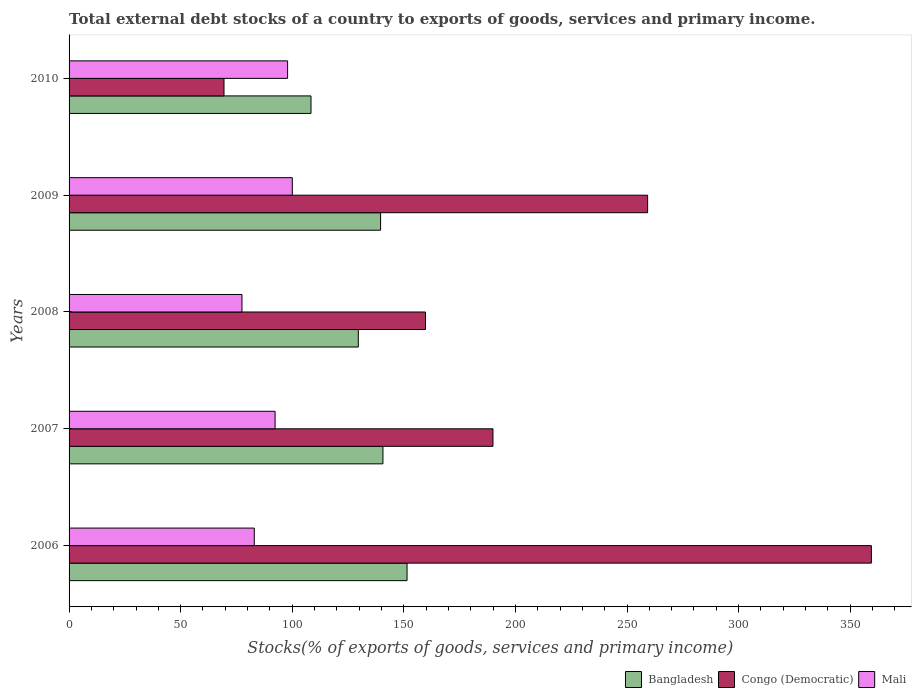How many groups of bars are there?
Provide a succinct answer. 5. Are the number of bars per tick equal to the number of legend labels?
Provide a short and direct response. Yes. How many bars are there on the 3rd tick from the bottom?
Your answer should be compact. 3. What is the label of the 4th group of bars from the top?
Offer a very short reply. 2007. In how many cases, is the number of bars for a given year not equal to the number of legend labels?
Give a very brief answer. 0. What is the total debt stocks in Mali in 2009?
Ensure brevity in your answer.  100.03. Across all years, what is the maximum total debt stocks in Mali?
Keep it short and to the point. 100.03. Across all years, what is the minimum total debt stocks in Congo (Democratic)?
Your answer should be very brief. 69.42. In which year was the total debt stocks in Mali maximum?
Offer a terse response. 2009. In which year was the total debt stocks in Bangladesh minimum?
Your response must be concise. 2010. What is the total total debt stocks in Congo (Democratic) in the graph?
Provide a succinct answer. 1037.78. What is the difference between the total debt stocks in Mali in 2006 and that in 2007?
Your answer should be compact. -9.32. What is the difference between the total debt stocks in Mali in 2010 and the total debt stocks in Congo (Democratic) in 2006?
Your answer should be very brief. -261.57. What is the average total debt stocks in Mali per year?
Keep it short and to the point. 90.14. In the year 2006, what is the difference between the total debt stocks in Congo (Democratic) and total debt stocks in Bangladesh?
Ensure brevity in your answer.  208.05. What is the ratio of the total debt stocks in Mali in 2007 to that in 2008?
Offer a very short reply. 1.19. Is the total debt stocks in Bangladesh in 2006 less than that in 2010?
Your response must be concise. No. Is the difference between the total debt stocks in Congo (Democratic) in 2006 and 2007 greater than the difference between the total debt stocks in Bangladesh in 2006 and 2007?
Keep it short and to the point. Yes. What is the difference between the highest and the second highest total debt stocks in Mali?
Offer a terse response. 2.12. What is the difference between the highest and the lowest total debt stocks in Congo (Democratic)?
Give a very brief answer. 290.07. In how many years, is the total debt stocks in Mali greater than the average total debt stocks in Mali taken over all years?
Provide a succinct answer. 3. Is the sum of the total debt stocks in Congo (Democratic) in 2008 and 2009 greater than the maximum total debt stocks in Mali across all years?
Offer a terse response. Yes. What does the 1st bar from the top in 2009 represents?
Offer a very short reply. Mali. What does the 2nd bar from the bottom in 2010 represents?
Ensure brevity in your answer.  Congo (Democratic). How many bars are there?
Your answer should be compact. 15. How many years are there in the graph?
Your answer should be very brief. 5. What is the difference between two consecutive major ticks on the X-axis?
Keep it short and to the point. 50. Are the values on the major ticks of X-axis written in scientific E-notation?
Make the answer very short. No. Does the graph contain any zero values?
Make the answer very short. No. Does the graph contain grids?
Ensure brevity in your answer.  No. Where does the legend appear in the graph?
Ensure brevity in your answer.  Bottom right. How are the legend labels stacked?
Your response must be concise. Horizontal. What is the title of the graph?
Make the answer very short. Total external debt stocks of a country to exports of goods, services and primary income. What is the label or title of the X-axis?
Offer a terse response. Stocks(% of exports of goods, services and primary income). What is the Stocks(% of exports of goods, services and primary income) of Bangladesh in 2006?
Make the answer very short. 151.43. What is the Stocks(% of exports of goods, services and primary income) of Congo (Democratic) in 2006?
Your answer should be very brief. 359.49. What is the Stocks(% of exports of goods, services and primary income) of Mali in 2006?
Offer a very short reply. 82.99. What is the Stocks(% of exports of goods, services and primary income) in Bangladesh in 2007?
Ensure brevity in your answer.  140.64. What is the Stocks(% of exports of goods, services and primary income) in Congo (Democratic) in 2007?
Provide a short and direct response. 189.94. What is the Stocks(% of exports of goods, services and primary income) of Mali in 2007?
Offer a terse response. 92.31. What is the Stocks(% of exports of goods, services and primary income) in Bangladesh in 2008?
Ensure brevity in your answer.  129.6. What is the Stocks(% of exports of goods, services and primary income) of Congo (Democratic) in 2008?
Your answer should be compact. 159.7. What is the Stocks(% of exports of goods, services and primary income) of Mali in 2008?
Offer a very short reply. 77.47. What is the Stocks(% of exports of goods, services and primary income) of Bangladesh in 2009?
Make the answer very short. 139.58. What is the Stocks(% of exports of goods, services and primary income) in Congo (Democratic) in 2009?
Your response must be concise. 259.23. What is the Stocks(% of exports of goods, services and primary income) of Mali in 2009?
Ensure brevity in your answer.  100.03. What is the Stocks(% of exports of goods, services and primary income) in Bangladesh in 2010?
Your response must be concise. 108.4. What is the Stocks(% of exports of goods, services and primary income) in Congo (Democratic) in 2010?
Your response must be concise. 69.42. What is the Stocks(% of exports of goods, services and primary income) of Mali in 2010?
Ensure brevity in your answer.  97.91. Across all years, what is the maximum Stocks(% of exports of goods, services and primary income) of Bangladesh?
Keep it short and to the point. 151.43. Across all years, what is the maximum Stocks(% of exports of goods, services and primary income) of Congo (Democratic)?
Provide a short and direct response. 359.49. Across all years, what is the maximum Stocks(% of exports of goods, services and primary income) in Mali?
Your answer should be compact. 100.03. Across all years, what is the minimum Stocks(% of exports of goods, services and primary income) in Bangladesh?
Offer a very short reply. 108.4. Across all years, what is the minimum Stocks(% of exports of goods, services and primary income) in Congo (Democratic)?
Offer a very short reply. 69.42. Across all years, what is the minimum Stocks(% of exports of goods, services and primary income) in Mali?
Your answer should be compact. 77.47. What is the total Stocks(% of exports of goods, services and primary income) in Bangladesh in the graph?
Offer a very short reply. 669.65. What is the total Stocks(% of exports of goods, services and primary income) in Congo (Democratic) in the graph?
Make the answer very short. 1037.78. What is the total Stocks(% of exports of goods, services and primary income) in Mali in the graph?
Your response must be concise. 450.72. What is the difference between the Stocks(% of exports of goods, services and primary income) of Bangladesh in 2006 and that in 2007?
Provide a short and direct response. 10.8. What is the difference between the Stocks(% of exports of goods, services and primary income) in Congo (Democratic) in 2006 and that in 2007?
Provide a succinct answer. 169.55. What is the difference between the Stocks(% of exports of goods, services and primary income) in Mali in 2006 and that in 2007?
Provide a short and direct response. -9.32. What is the difference between the Stocks(% of exports of goods, services and primary income) in Bangladesh in 2006 and that in 2008?
Your answer should be compact. 21.83. What is the difference between the Stocks(% of exports of goods, services and primary income) in Congo (Democratic) in 2006 and that in 2008?
Offer a very short reply. 199.79. What is the difference between the Stocks(% of exports of goods, services and primary income) of Mali in 2006 and that in 2008?
Offer a very short reply. 5.52. What is the difference between the Stocks(% of exports of goods, services and primary income) in Bangladesh in 2006 and that in 2009?
Give a very brief answer. 11.86. What is the difference between the Stocks(% of exports of goods, services and primary income) in Congo (Democratic) in 2006 and that in 2009?
Offer a terse response. 100.25. What is the difference between the Stocks(% of exports of goods, services and primary income) of Mali in 2006 and that in 2009?
Offer a terse response. -17.04. What is the difference between the Stocks(% of exports of goods, services and primary income) in Bangladesh in 2006 and that in 2010?
Provide a succinct answer. 43.03. What is the difference between the Stocks(% of exports of goods, services and primary income) in Congo (Democratic) in 2006 and that in 2010?
Make the answer very short. 290.07. What is the difference between the Stocks(% of exports of goods, services and primary income) in Mali in 2006 and that in 2010?
Your response must be concise. -14.92. What is the difference between the Stocks(% of exports of goods, services and primary income) of Bangladesh in 2007 and that in 2008?
Provide a succinct answer. 11.03. What is the difference between the Stocks(% of exports of goods, services and primary income) in Congo (Democratic) in 2007 and that in 2008?
Offer a very short reply. 30.23. What is the difference between the Stocks(% of exports of goods, services and primary income) of Mali in 2007 and that in 2008?
Your response must be concise. 14.84. What is the difference between the Stocks(% of exports of goods, services and primary income) of Bangladesh in 2007 and that in 2009?
Provide a short and direct response. 1.06. What is the difference between the Stocks(% of exports of goods, services and primary income) of Congo (Democratic) in 2007 and that in 2009?
Ensure brevity in your answer.  -69.3. What is the difference between the Stocks(% of exports of goods, services and primary income) in Mali in 2007 and that in 2009?
Offer a very short reply. -7.72. What is the difference between the Stocks(% of exports of goods, services and primary income) of Bangladesh in 2007 and that in 2010?
Your answer should be very brief. 32.23. What is the difference between the Stocks(% of exports of goods, services and primary income) in Congo (Democratic) in 2007 and that in 2010?
Offer a terse response. 120.52. What is the difference between the Stocks(% of exports of goods, services and primary income) of Mali in 2007 and that in 2010?
Your answer should be compact. -5.6. What is the difference between the Stocks(% of exports of goods, services and primary income) in Bangladesh in 2008 and that in 2009?
Your answer should be very brief. -9.98. What is the difference between the Stocks(% of exports of goods, services and primary income) of Congo (Democratic) in 2008 and that in 2009?
Make the answer very short. -99.53. What is the difference between the Stocks(% of exports of goods, services and primary income) of Mali in 2008 and that in 2009?
Provide a short and direct response. -22.56. What is the difference between the Stocks(% of exports of goods, services and primary income) in Bangladesh in 2008 and that in 2010?
Give a very brief answer. 21.2. What is the difference between the Stocks(% of exports of goods, services and primary income) in Congo (Democratic) in 2008 and that in 2010?
Give a very brief answer. 90.29. What is the difference between the Stocks(% of exports of goods, services and primary income) in Mali in 2008 and that in 2010?
Provide a succinct answer. -20.44. What is the difference between the Stocks(% of exports of goods, services and primary income) of Bangladesh in 2009 and that in 2010?
Keep it short and to the point. 31.18. What is the difference between the Stocks(% of exports of goods, services and primary income) in Congo (Democratic) in 2009 and that in 2010?
Your answer should be very brief. 189.82. What is the difference between the Stocks(% of exports of goods, services and primary income) in Mali in 2009 and that in 2010?
Provide a succinct answer. 2.12. What is the difference between the Stocks(% of exports of goods, services and primary income) of Bangladesh in 2006 and the Stocks(% of exports of goods, services and primary income) of Congo (Democratic) in 2007?
Offer a very short reply. -38.5. What is the difference between the Stocks(% of exports of goods, services and primary income) in Bangladesh in 2006 and the Stocks(% of exports of goods, services and primary income) in Mali in 2007?
Give a very brief answer. 59.12. What is the difference between the Stocks(% of exports of goods, services and primary income) in Congo (Democratic) in 2006 and the Stocks(% of exports of goods, services and primary income) in Mali in 2007?
Keep it short and to the point. 267.17. What is the difference between the Stocks(% of exports of goods, services and primary income) of Bangladesh in 2006 and the Stocks(% of exports of goods, services and primary income) of Congo (Democratic) in 2008?
Your response must be concise. -8.27. What is the difference between the Stocks(% of exports of goods, services and primary income) in Bangladesh in 2006 and the Stocks(% of exports of goods, services and primary income) in Mali in 2008?
Your answer should be very brief. 73.96. What is the difference between the Stocks(% of exports of goods, services and primary income) of Congo (Democratic) in 2006 and the Stocks(% of exports of goods, services and primary income) of Mali in 2008?
Your answer should be compact. 282.02. What is the difference between the Stocks(% of exports of goods, services and primary income) of Bangladesh in 2006 and the Stocks(% of exports of goods, services and primary income) of Congo (Democratic) in 2009?
Your response must be concise. -107.8. What is the difference between the Stocks(% of exports of goods, services and primary income) in Bangladesh in 2006 and the Stocks(% of exports of goods, services and primary income) in Mali in 2009?
Offer a very short reply. 51.4. What is the difference between the Stocks(% of exports of goods, services and primary income) in Congo (Democratic) in 2006 and the Stocks(% of exports of goods, services and primary income) in Mali in 2009?
Provide a short and direct response. 259.46. What is the difference between the Stocks(% of exports of goods, services and primary income) of Bangladesh in 2006 and the Stocks(% of exports of goods, services and primary income) of Congo (Democratic) in 2010?
Your answer should be very brief. 82.02. What is the difference between the Stocks(% of exports of goods, services and primary income) in Bangladesh in 2006 and the Stocks(% of exports of goods, services and primary income) in Mali in 2010?
Provide a succinct answer. 53.52. What is the difference between the Stocks(% of exports of goods, services and primary income) in Congo (Democratic) in 2006 and the Stocks(% of exports of goods, services and primary income) in Mali in 2010?
Provide a short and direct response. 261.57. What is the difference between the Stocks(% of exports of goods, services and primary income) in Bangladesh in 2007 and the Stocks(% of exports of goods, services and primary income) in Congo (Democratic) in 2008?
Ensure brevity in your answer.  -19.07. What is the difference between the Stocks(% of exports of goods, services and primary income) in Bangladesh in 2007 and the Stocks(% of exports of goods, services and primary income) in Mali in 2008?
Make the answer very short. 63.16. What is the difference between the Stocks(% of exports of goods, services and primary income) of Congo (Democratic) in 2007 and the Stocks(% of exports of goods, services and primary income) of Mali in 2008?
Your answer should be compact. 112.46. What is the difference between the Stocks(% of exports of goods, services and primary income) in Bangladesh in 2007 and the Stocks(% of exports of goods, services and primary income) in Congo (Democratic) in 2009?
Provide a short and direct response. -118.6. What is the difference between the Stocks(% of exports of goods, services and primary income) of Bangladesh in 2007 and the Stocks(% of exports of goods, services and primary income) of Mali in 2009?
Your answer should be very brief. 40.61. What is the difference between the Stocks(% of exports of goods, services and primary income) in Congo (Democratic) in 2007 and the Stocks(% of exports of goods, services and primary income) in Mali in 2009?
Offer a terse response. 89.9. What is the difference between the Stocks(% of exports of goods, services and primary income) in Bangladesh in 2007 and the Stocks(% of exports of goods, services and primary income) in Congo (Democratic) in 2010?
Ensure brevity in your answer.  71.22. What is the difference between the Stocks(% of exports of goods, services and primary income) of Bangladesh in 2007 and the Stocks(% of exports of goods, services and primary income) of Mali in 2010?
Your answer should be very brief. 42.72. What is the difference between the Stocks(% of exports of goods, services and primary income) in Congo (Democratic) in 2007 and the Stocks(% of exports of goods, services and primary income) in Mali in 2010?
Make the answer very short. 92.02. What is the difference between the Stocks(% of exports of goods, services and primary income) of Bangladesh in 2008 and the Stocks(% of exports of goods, services and primary income) of Congo (Democratic) in 2009?
Offer a very short reply. -129.63. What is the difference between the Stocks(% of exports of goods, services and primary income) of Bangladesh in 2008 and the Stocks(% of exports of goods, services and primary income) of Mali in 2009?
Provide a short and direct response. 29.57. What is the difference between the Stocks(% of exports of goods, services and primary income) of Congo (Democratic) in 2008 and the Stocks(% of exports of goods, services and primary income) of Mali in 2009?
Your answer should be compact. 59.67. What is the difference between the Stocks(% of exports of goods, services and primary income) in Bangladesh in 2008 and the Stocks(% of exports of goods, services and primary income) in Congo (Democratic) in 2010?
Your response must be concise. 60.19. What is the difference between the Stocks(% of exports of goods, services and primary income) of Bangladesh in 2008 and the Stocks(% of exports of goods, services and primary income) of Mali in 2010?
Your answer should be very brief. 31.69. What is the difference between the Stocks(% of exports of goods, services and primary income) in Congo (Democratic) in 2008 and the Stocks(% of exports of goods, services and primary income) in Mali in 2010?
Provide a succinct answer. 61.79. What is the difference between the Stocks(% of exports of goods, services and primary income) of Bangladesh in 2009 and the Stocks(% of exports of goods, services and primary income) of Congo (Democratic) in 2010?
Your response must be concise. 70.16. What is the difference between the Stocks(% of exports of goods, services and primary income) in Bangladesh in 2009 and the Stocks(% of exports of goods, services and primary income) in Mali in 2010?
Keep it short and to the point. 41.66. What is the difference between the Stocks(% of exports of goods, services and primary income) in Congo (Democratic) in 2009 and the Stocks(% of exports of goods, services and primary income) in Mali in 2010?
Offer a very short reply. 161.32. What is the average Stocks(% of exports of goods, services and primary income) in Bangladesh per year?
Your answer should be compact. 133.93. What is the average Stocks(% of exports of goods, services and primary income) of Congo (Democratic) per year?
Give a very brief answer. 207.56. What is the average Stocks(% of exports of goods, services and primary income) of Mali per year?
Offer a terse response. 90.14. In the year 2006, what is the difference between the Stocks(% of exports of goods, services and primary income) of Bangladesh and Stocks(% of exports of goods, services and primary income) of Congo (Democratic)?
Keep it short and to the point. -208.05. In the year 2006, what is the difference between the Stocks(% of exports of goods, services and primary income) of Bangladesh and Stocks(% of exports of goods, services and primary income) of Mali?
Provide a succinct answer. 68.44. In the year 2006, what is the difference between the Stocks(% of exports of goods, services and primary income) in Congo (Democratic) and Stocks(% of exports of goods, services and primary income) in Mali?
Your answer should be compact. 276.5. In the year 2007, what is the difference between the Stocks(% of exports of goods, services and primary income) of Bangladesh and Stocks(% of exports of goods, services and primary income) of Congo (Democratic)?
Your response must be concise. -49.3. In the year 2007, what is the difference between the Stocks(% of exports of goods, services and primary income) in Bangladesh and Stocks(% of exports of goods, services and primary income) in Mali?
Offer a very short reply. 48.32. In the year 2007, what is the difference between the Stocks(% of exports of goods, services and primary income) in Congo (Democratic) and Stocks(% of exports of goods, services and primary income) in Mali?
Make the answer very short. 97.62. In the year 2008, what is the difference between the Stocks(% of exports of goods, services and primary income) of Bangladesh and Stocks(% of exports of goods, services and primary income) of Congo (Democratic)?
Keep it short and to the point. -30.1. In the year 2008, what is the difference between the Stocks(% of exports of goods, services and primary income) in Bangladesh and Stocks(% of exports of goods, services and primary income) in Mali?
Give a very brief answer. 52.13. In the year 2008, what is the difference between the Stocks(% of exports of goods, services and primary income) of Congo (Democratic) and Stocks(% of exports of goods, services and primary income) of Mali?
Provide a short and direct response. 82.23. In the year 2009, what is the difference between the Stocks(% of exports of goods, services and primary income) of Bangladesh and Stocks(% of exports of goods, services and primary income) of Congo (Democratic)?
Make the answer very short. -119.66. In the year 2009, what is the difference between the Stocks(% of exports of goods, services and primary income) in Bangladesh and Stocks(% of exports of goods, services and primary income) in Mali?
Your answer should be very brief. 39.55. In the year 2009, what is the difference between the Stocks(% of exports of goods, services and primary income) in Congo (Democratic) and Stocks(% of exports of goods, services and primary income) in Mali?
Provide a succinct answer. 159.2. In the year 2010, what is the difference between the Stocks(% of exports of goods, services and primary income) in Bangladesh and Stocks(% of exports of goods, services and primary income) in Congo (Democratic)?
Your response must be concise. 38.99. In the year 2010, what is the difference between the Stocks(% of exports of goods, services and primary income) of Bangladesh and Stocks(% of exports of goods, services and primary income) of Mali?
Keep it short and to the point. 10.49. In the year 2010, what is the difference between the Stocks(% of exports of goods, services and primary income) of Congo (Democratic) and Stocks(% of exports of goods, services and primary income) of Mali?
Offer a terse response. -28.5. What is the ratio of the Stocks(% of exports of goods, services and primary income) in Bangladesh in 2006 to that in 2007?
Offer a terse response. 1.08. What is the ratio of the Stocks(% of exports of goods, services and primary income) of Congo (Democratic) in 2006 to that in 2007?
Your answer should be compact. 1.89. What is the ratio of the Stocks(% of exports of goods, services and primary income) of Mali in 2006 to that in 2007?
Ensure brevity in your answer.  0.9. What is the ratio of the Stocks(% of exports of goods, services and primary income) in Bangladesh in 2006 to that in 2008?
Keep it short and to the point. 1.17. What is the ratio of the Stocks(% of exports of goods, services and primary income) in Congo (Democratic) in 2006 to that in 2008?
Make the answer very short. 2.25. What is the ratio of the Stocks(% of exports of goods, services and primary income) in Mali in 2006 to that in 2008?
Keep it short and to the point. 1.07. What is the ratio of the Stocks(% of exports of goods, services and primary income) in Bangladesh in 2006 to that in 2009?
Offer a terse response. 1.08. What is the ratio of the Stocks(% of exports of goods, services and primary income) in Congo (Democratic) in 2006 to that in 2009?
Keep it short and to the point. 1.39. What is the ratio of the Stocks(% of exports of goods, services and primary income) in Mali in 2006 to that in 2009?
Your answer should be very brief. 0.83. What is the ratio of the Stocks(% of exports of goods, services and primary income) in Bangladesh in 2006 to that in 2010?
Provide a short and direct response. 1.4. What is the ratio of the Stocks(% of exports of goods, services and primary income) of Congo (Democratic) in 2006 to that in 2010?
Your response must be concise. 5.18. What is the ratio of the Stocks(% of exports of goods, services and primary income) in Mali in 2006 to that in 2010?
Your answer should be compact. 0.85. What is the ratio of the Stocks(% of exports of goods, services and primary income) of Bangladesh in 2007 to that in 2008?
Give a very brief answer. 1.09. What is the ratio of the Stocks(% of exports of goods, services and primary income) of Congo (Democratic) in 2007 to that in 2008?
Offer a very short reply. 1.19. What is the ratio of the Stocks(% of exports of goods, services and primary income) of Mali in 2007 to that in 2008?
Keep it short and to the point. 1.19. What is the ratio of the Stocks(% of exports of goods, services and primary income) in Bangladesh in 2007 to that in 2009?
Your answer should be compact. 1.01. What is the ratio of the Stocks(% of exports of goods, services and primary income) of Congo (Democratic) in 2007 to that in 2009?
Your answer should be compact. 0.73. What is the ratio of the Stocks(% of exports of goods, services and primary income) of Mali in 2007 to that in 2009?
Provide a short and direct response. 0.92. What is the ratio of the Stocks(% of exports of goods, services and primary income) in Bangladesh in 2007 to that in 2010?
Your response must be concise. 1.3. What is the ratio of the Stocks(% of exports of goods, services and primary income) in Congo (Democratic) in 2007 to that in 2010?
Your answer should be compact. 2.74. What is the ratio of the Stocks(% of exports of goods, services and primary income) in Mali in 2007 to that in 2010?
Give a very brief answer. 0.94. What is the ratio of the Stocks(% of exports of goods, services and primary income) in Bangladesh in 2008 to that in 2009?
Provide a succinct answer. 0.93. What is the ratio of the Stocks(% of exports of goods, services and primary income) in Congo (Democratic) in 2008 to that in 2009?
Give a very brief answer. 0.62. What is the ratio of the Stocks(% of exports of goods, services and primary income) in Mali in 2008 to that in 2009?
Offer a terse response. 0.77. What is the ratio of the Stocks(% of exports of goods, services and primary income) of Bangladesh in 2008 to that in 2010?
Make the answer very short. 1.2. What is the ratio of the Stocks(% of exports of goods, services and primary income) of Congo (Democratic) in 2008 to that in 2010?
Provide a succinct answer. 2.3. What is the ratio of the Stocks(% of exports of goods, services and primary income) in Mali in 2008 to that in 2010?
Provide a short and direct response. 0.79. What is the ratio of the Stocks(% of exports of goods, services and primary income) of Bangladesh in 2009 to that in 2010?
Your answer should be very brief. 1.29. What is the ratio of the Stocks(% of exports of goods, services and primary income) in Congo (Democratic) in 2009 to that in 2010?
Give a very brief answer. 3.73. What is the ratio of the Stocks(% of exports of goods, services and primary income) in Mali in 2009 to that in 2010?
Offer a very short reply. 1.02. What is the difference between the highest and the second highest Stocks(% of exports of goods, services and primary income) of Bangladesh?
Your response must be concise. 10.8. What is the difference between the highest and the second highest Stocks(% of exports of goods, services and primary income) in Congo (Democratic)?
Offer a very short reply. 100.25. What is the difference between the highest and the second highest Stocks(% of exports of goods, services and primary income) of Mali?
Provide a short and direct response. 2.12. What is the difference between the highest and the lowest Stocks(% of exports of goods, services and primary income) in Bangladesh?
Give a very brief answer. 43.03. What is the difference between the highest and the lowest Stocks(% of exports of goods, services and primary income) of Congo (Democratic)?
Offer a very short reply. 290.07. What is the difference between the highest and the lowest Stocks(% of exports of goods, services and primary income) in Mali?
Your answer should be compact. 22.56. 